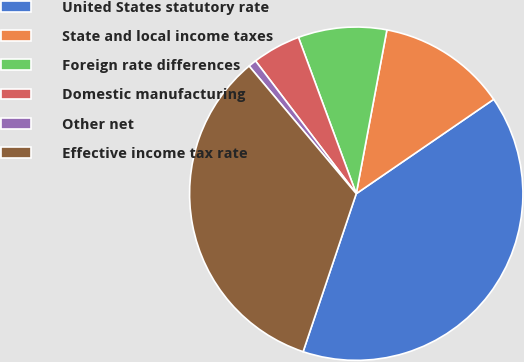Convert chart. <chart><loc_0><loc_0><loc_500><loc_500><pie_chart><fcel>United States statutory rate<fcel>State and local income taxes<fcel>Foreign rate differences<fcel>Domestic manufacturing<fcel>Other net<fcel>Effective income tax rate<nl><fcel>39.74%<fcel>12.48%<fcel>8.58%<fcel>4.69%<fcel>0.79%<fcel>33.72%<nl></chart> 